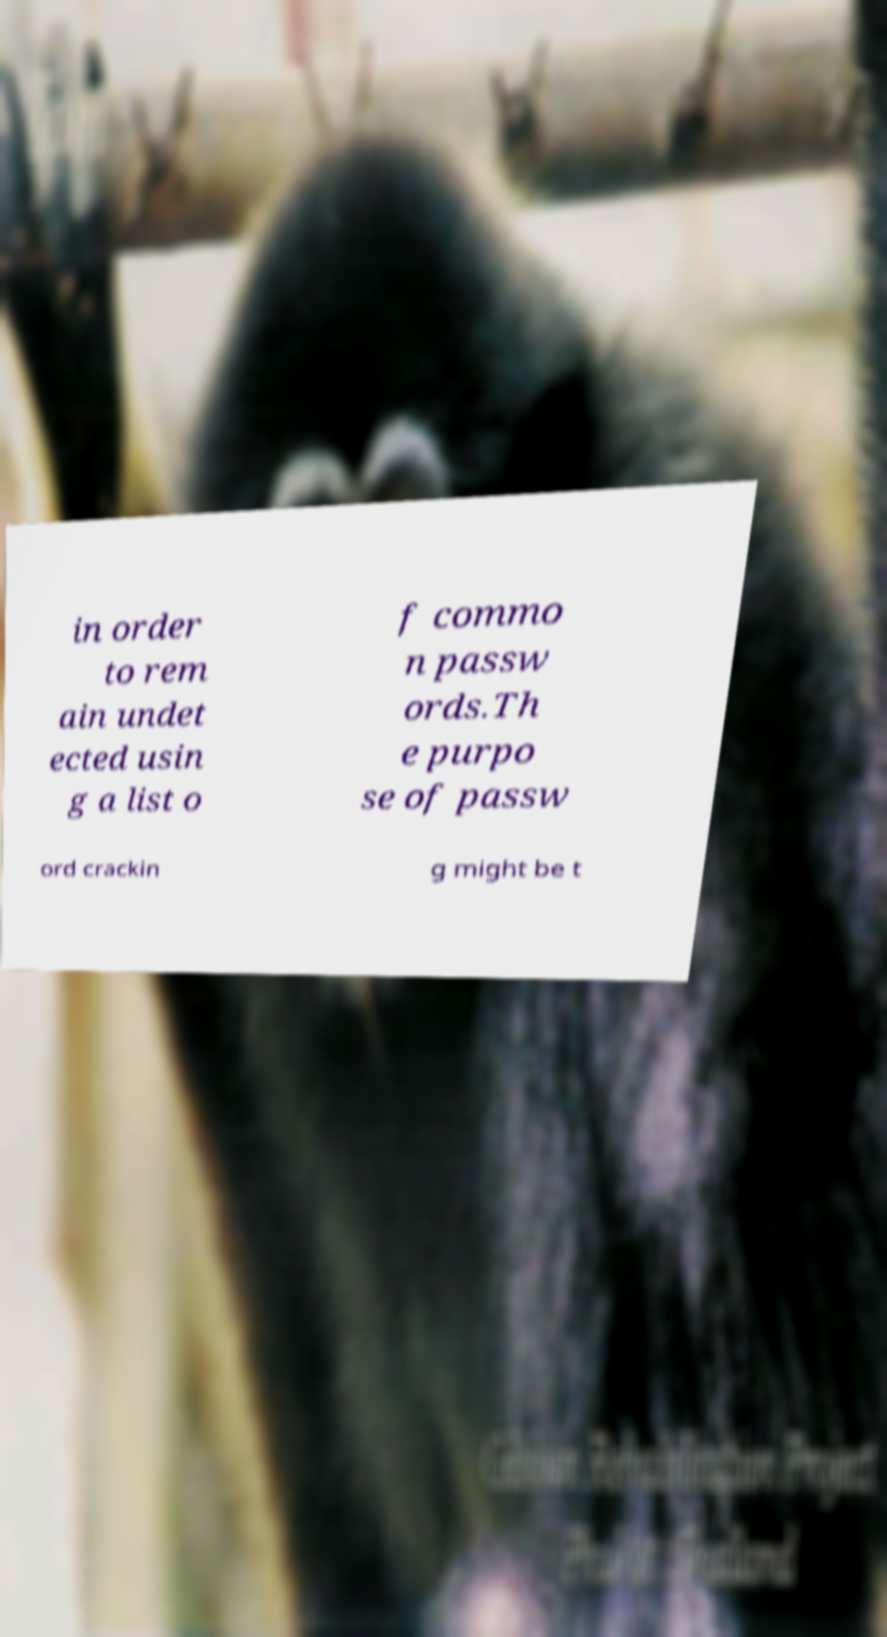There's text embedded in this image that I need extracted. Can you transcribe it verbatim? in order to rem ain undet ected usin g a list o f commo n passw ords.Th e purpo se of passw ord crackin g might be t 